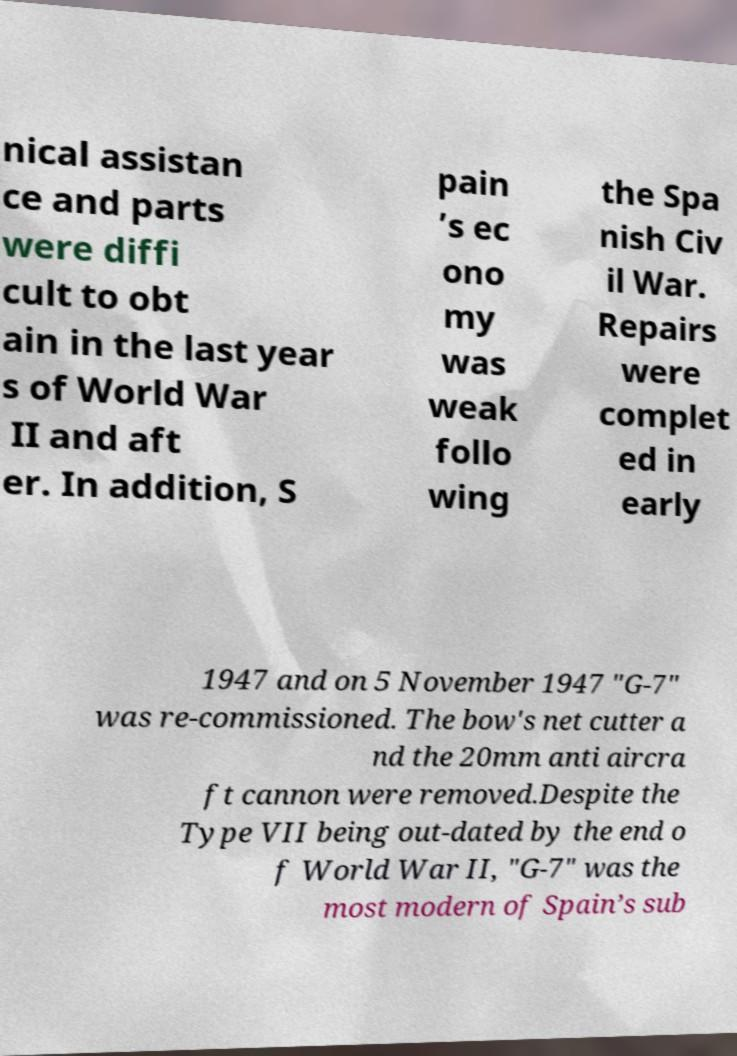Please identify and transcribe the text found in this image. nical assistan ce and parts were diffi cult to obt ain in the last year s of World War II and aft er. In addition, S pain ’s ec ono my was weak follo wing the Spa nish Civ il War. Repairs were complet ed in early 1947 and on 5 November 1947 "G-7" was re-commissioned. The bow's net cutter a nd the 20mm anti aircra ft cannon were removed.Despite the Type VII being out-dated by the end o f World War II, "G-7" was the most modern of Spain’s sub 